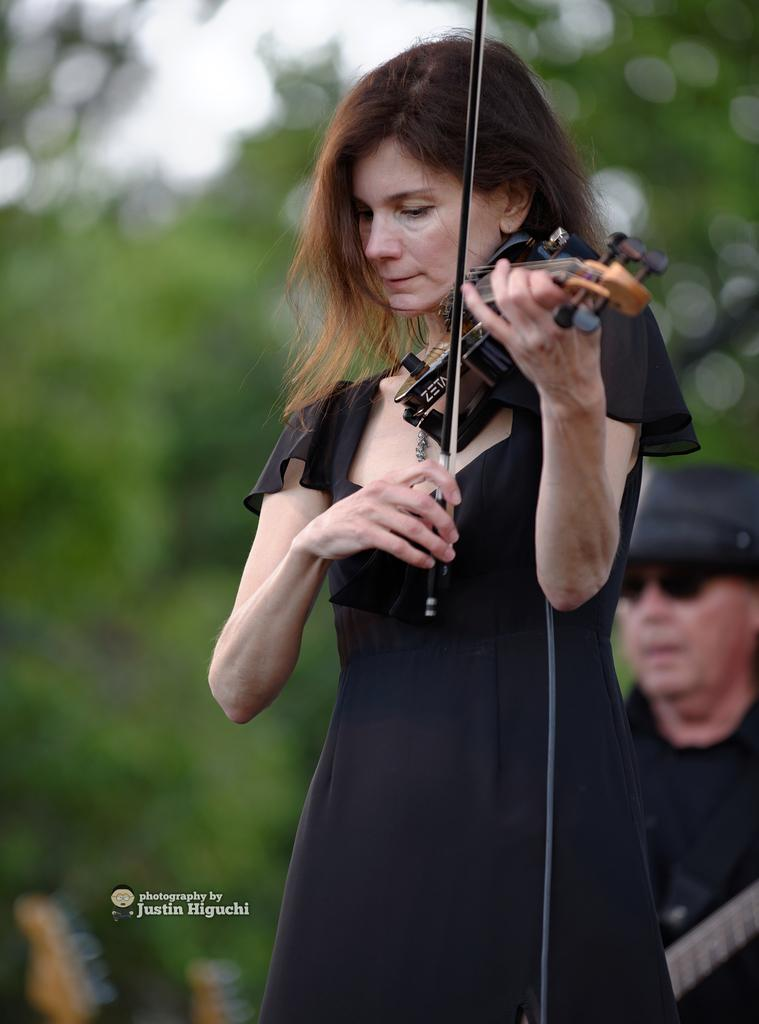What is the main subject of the image? There is a woman in the image. What is the woman holding in the image? The woman is holding a musical instrument. Can you describe the background of the image? There is a man and trees in the background of the image. How are the trees depicted in the image? The trees are blurred in the image. What type of power source is being used to fuel the tent in the image? There is no tent present in the image, so there is no power source for a tent. 